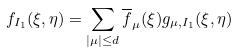<formula> <loc_0><loc_0><loc_500><loc_500>f _ { I _ { 1 } } ( \xi , \eta ) = \sum _ { | \mu | \leq d } { \overline { f } _ { \mu } ( \xi ) g _ { \mu , I _ { 1 } } ( \xi , \eta ) }</formula> 